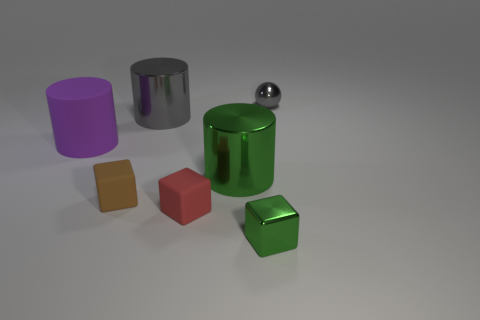Add 2 tiny green metal spheres. How many objects exist? 9 Subtract all cylinders. How many objects are left? 4 Add 1 tiny gray objects. How many tiny gray objects exist? 2 Subtract 0 yellow balls. How many objects are left? 7 Subtract all tiny green shiny objects. Subtract all large gray cylinders. How many objects are left? 5 Add 4 large green things. How many large green things are left? 5 